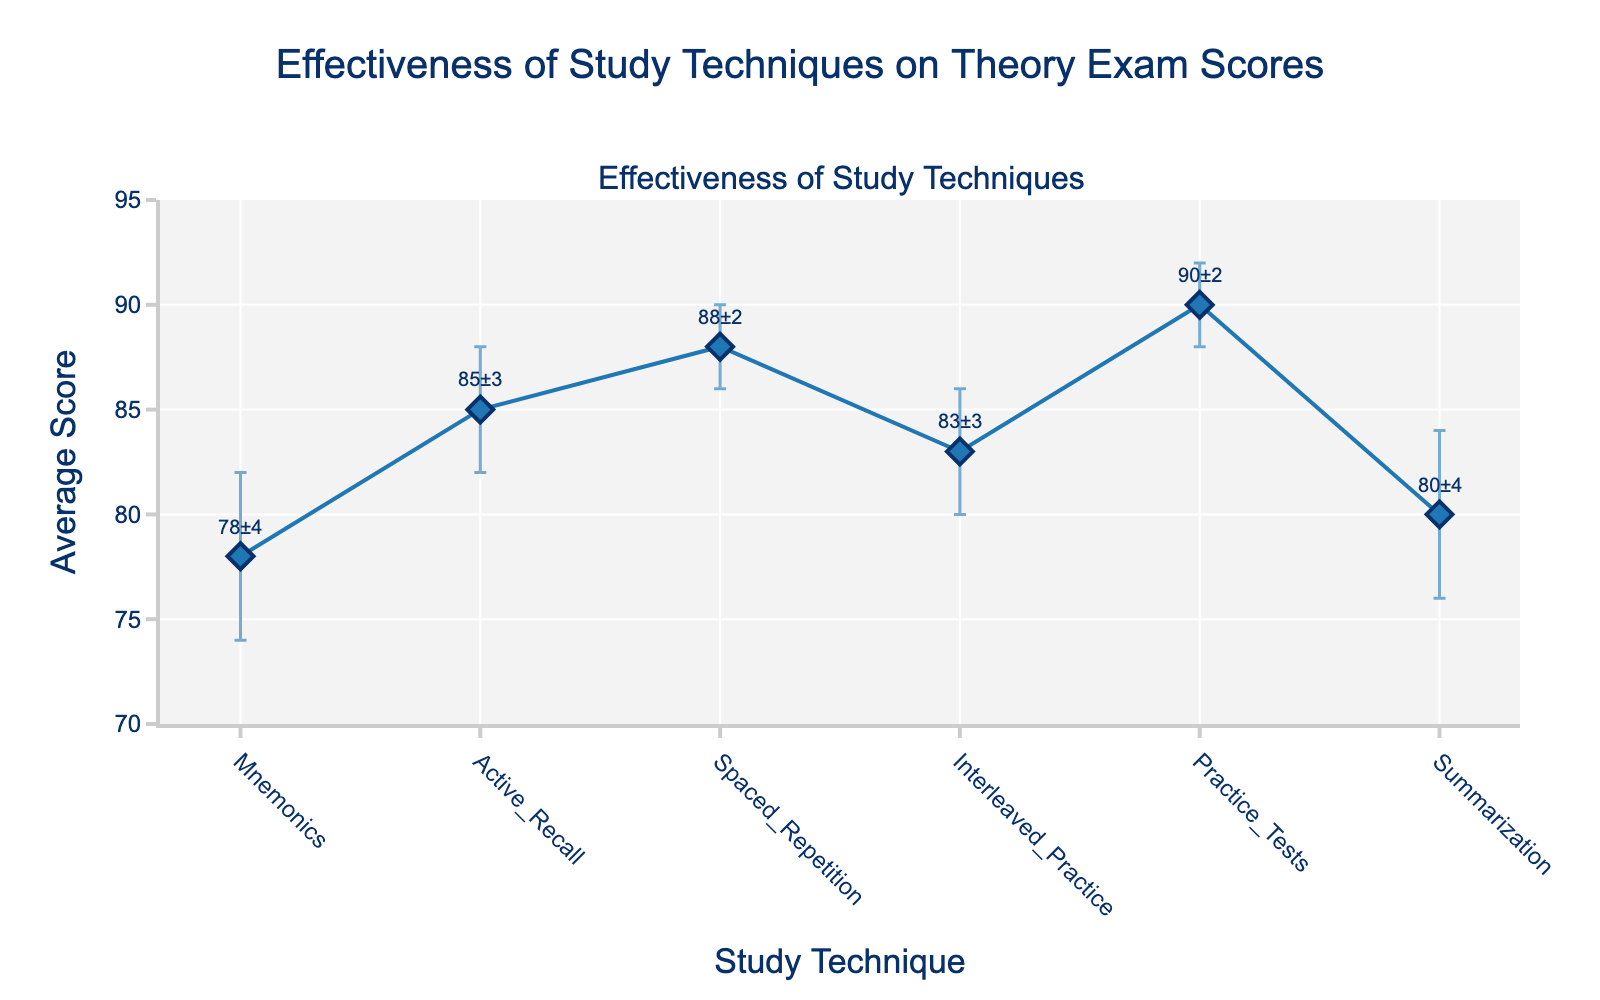What is the title of the figure? The title is clearly displayed at the top of the figure. It reads "Effectiveness of Study Techniques on Theory Exam Scores".
Answer: Effectiveness of Study Techniques on Theory Exam Scores What is the average score for the Practice Tests technique? The figure shows the score for each study technique with a label. The Practice Tests technique has an average score of 90.
Answer: 90 Which study technique has the smallest error margin? In the figure, the error margins are shown as the vertical lines on the data points. Spaced Repetition and Practice Tests both have the smallest error margin of 2.
Answer: Spaced Repetition and Practice Tests What's the difference in average scores between Mnemonics and Practice Tests techniques? Mnemonics has an average score of 78 and Practice Tests has an average score of 90. The difference is 90 - 78 = 12.
Answer: 12 What is the highest average score among the study techniques? By scanning the y-axis values for each point, the highest average score is for Practice Tests, which is 90.
Answer: 90 Which study technique has the lowest average score? The lowest data point on the y-axis corresponds to the Mnemonics technique, with an average score of 78.
Answer: Mnemonics How many study techniques have an average score above 80? By observing the y-axis values and counting the techniques with scores above 80: Active Recall, Spaced Repetition, Interleaved Practice, Practice Tests, and Summarization. There are 5 techniques.
Answer: 5 What's the combined error margin for Mnemonics and Summarization techniques? Mnemonics has an error margin of 4 and Summarization also has an error margin of 4. Adding them gives 4 + 4 = 8.
Answer: 8 Among the techniques with an average score above 85, which one has the largest error margin? Techniques with scores above 85 are Spaced Repetition and Practice Tests. Spaced Repetition has an error margin of 2, and Practice Tests also has an error margin of 2. They are equal.
Answer: Spaced Repetition and Practice Tests 